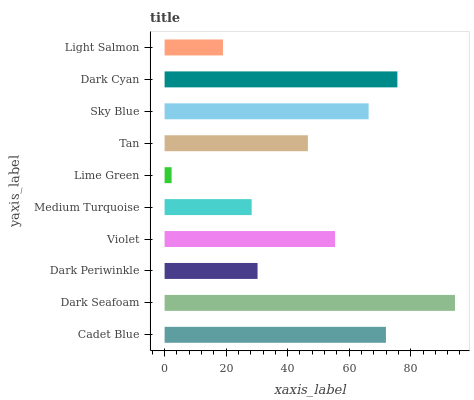Is Lime Green the minimum?
Answer yes or no. Yes. Is Dark Seafoam the maximum?
Answer yes or no. Yes. Is Dark Periwinkle the minimum?
Answer yes or no. No. Is Dark Periwinkle the maximum?
Answer yes or no. No. Is Dark Seafoam greater than Dark Periwinkle?
Answer yes or no. Yes. Is Dark Periwinkle less than Dark Seafoam?
Answer yes or no. Yes. Is Dark Periwinkle greater than Dark Seafoam?
Answer yes or no. No. Is Dark Seafoam less than Dark Periwinkle?
Answer yes or no. No. Is Violet the high median?
Answer yes or no. Yes. Is Tan the low median?
Answer yes or no. Yes. Is Sky Blue the high median?
Answer yes or no. No. Is Medium Turquoise the low median?
Answer yes or no. No. 